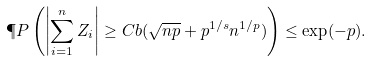Convert formula to latex. <formula><loc_0><loc_0><loc_500><loc_500>\P P \left ( \left | \sum _ { i = 1 } ^ { n } Z _ { i } \right | \geq C b ( \sqrt { n p } + p ^ { 1 / s } n ^ { 1 / p } ) \right ) \leq \exp ( - p ) .</formula> 